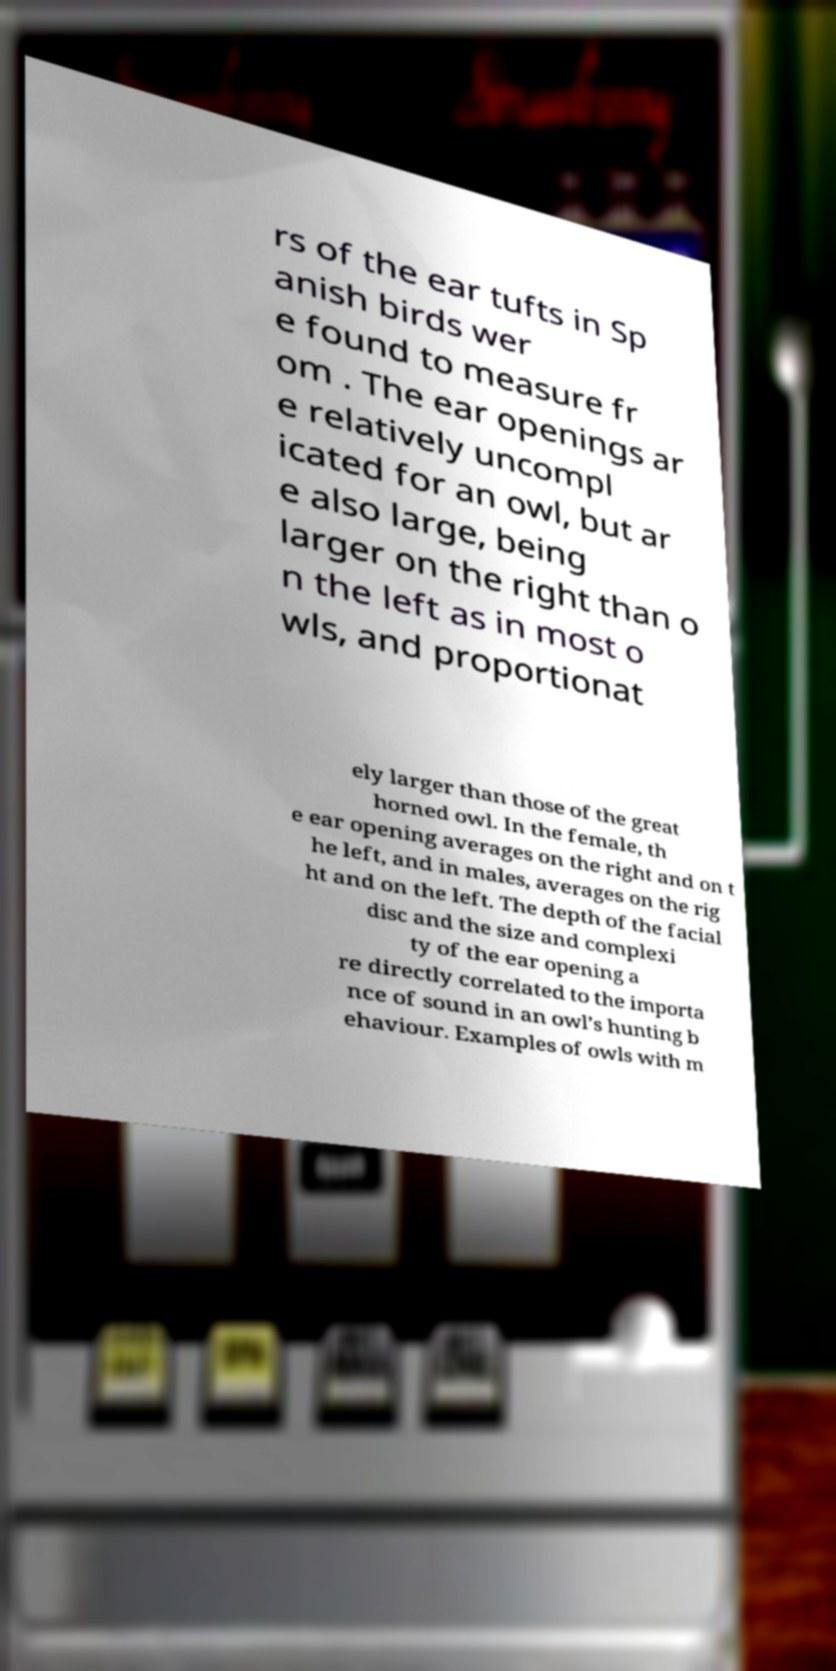Can you accurately transcribe the text from the provided image for me? rs of the ear tufts in Sp anish birds wer e found to measure fr om . The ear openings ar e relatively uncompl icated for an owl, but ar e also large, being larger on the right than o n the left as in most o wls, and proportionat ely larger than those of the great horned owl. In the female, th e ear opening averages on the right and on t he left, and in males, averages on the rig ht and on the left. The depth of the facial disc and the size and complexi ty of the ear opening a re directly correlated to the importa nce of sound in an owl’s hunting b ehaviour. Examples of owls with m 